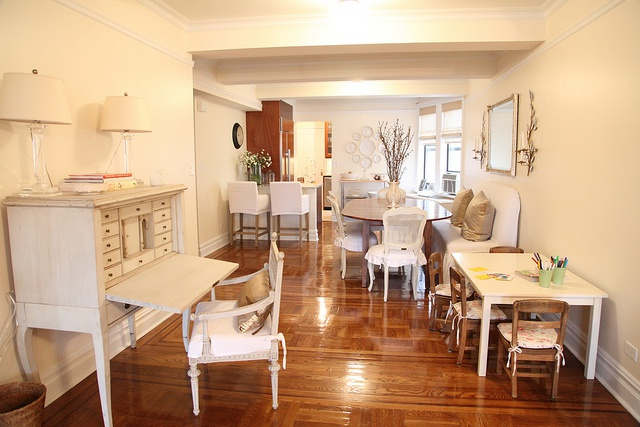Describe the objects in this image and their specific colors. I can see chair in tan, lightgray, and brown tones, dining table in tan, lightgray, and gray tones, chair in tan, maroon, brown, and salmon tones, chair in tan, lightgray, and darkgray tones, and chair in tan, maroon, and brown tones in this image. 